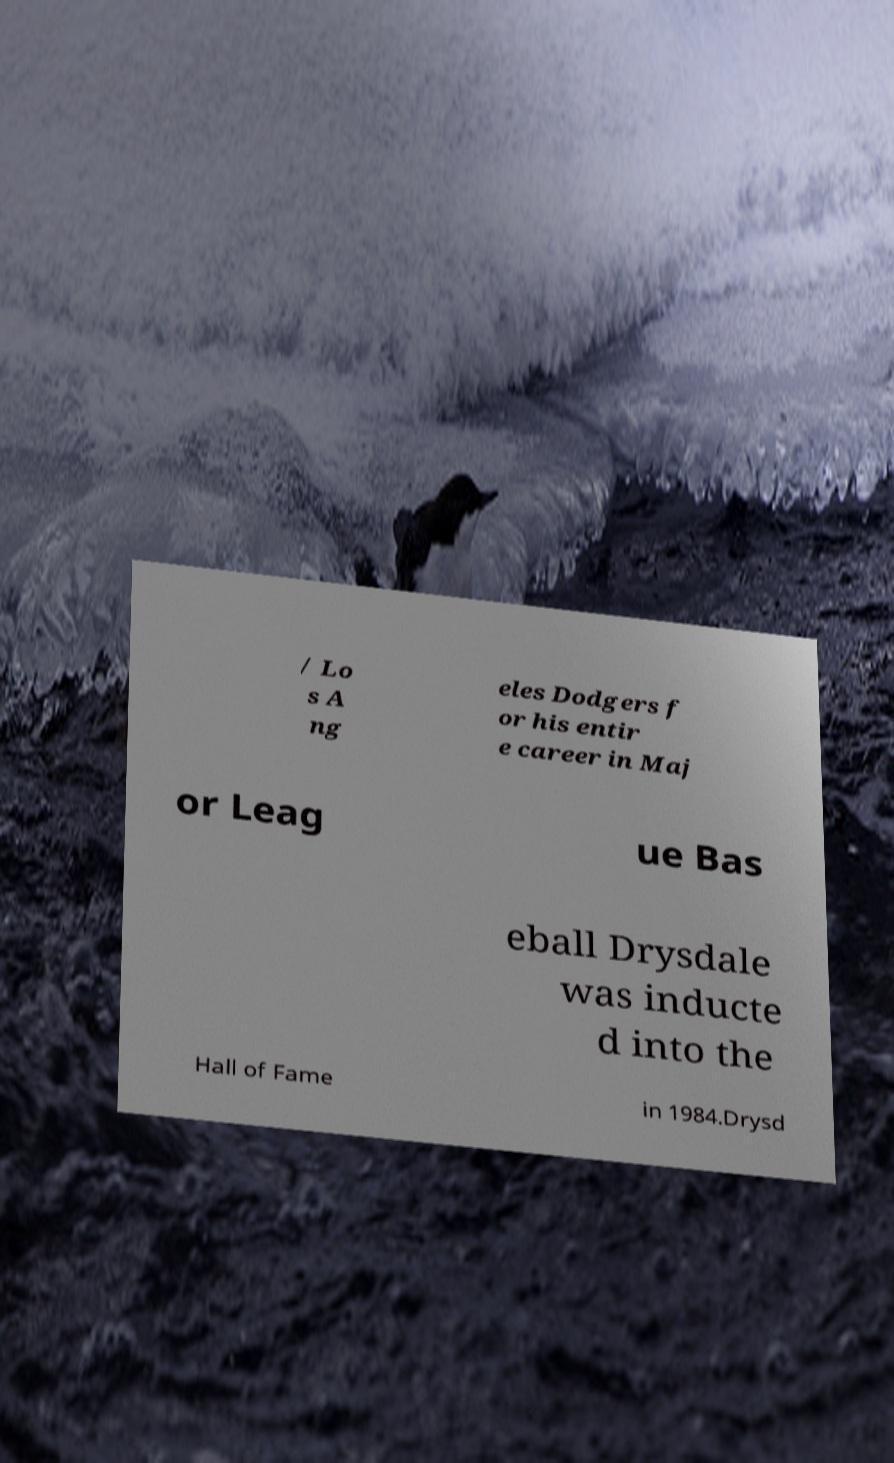Can you accurately transcribe the text from the provided image for me? / Lo s A ng eles Dodgers f or his entir e career in Maj or Leag ue Bas eball Drysdale was inducte d into the Hall of Fame in 1984.Drysd 